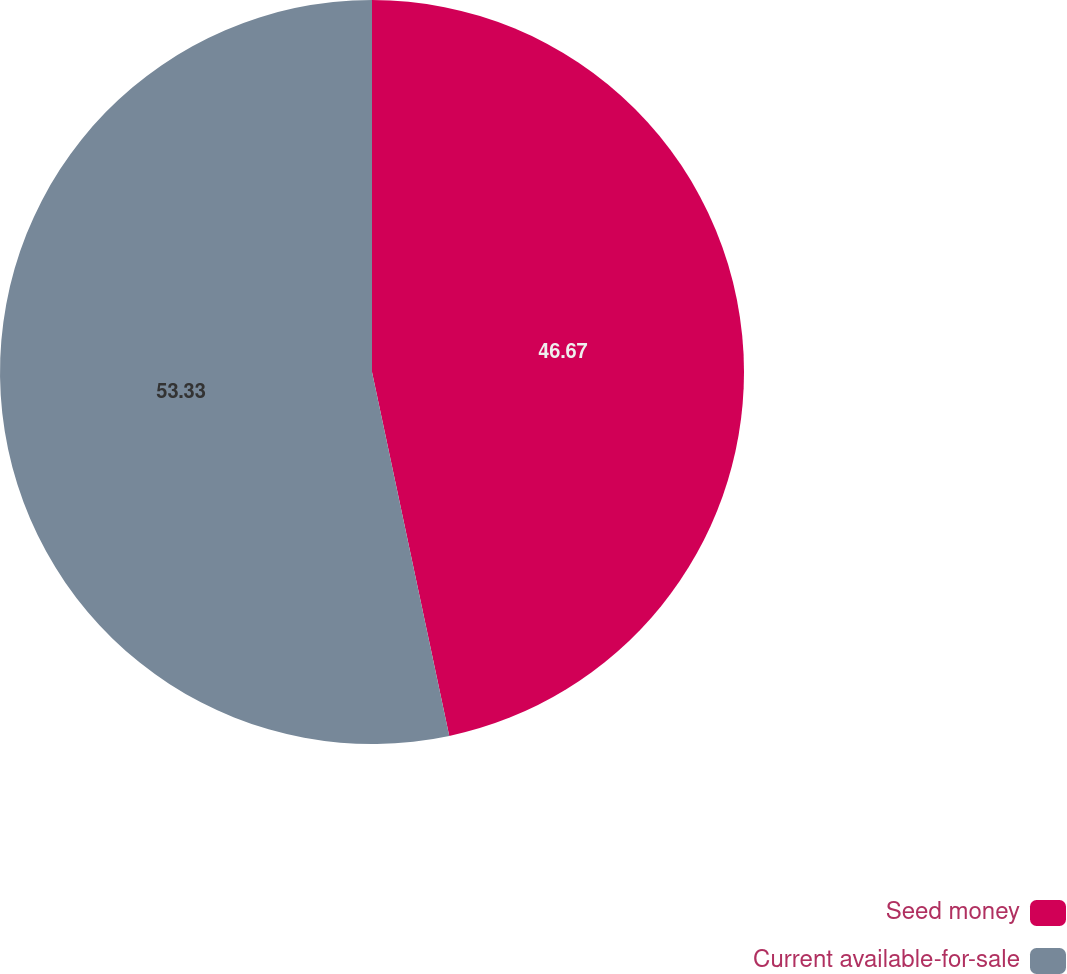Convert chart. <chart><loc_0><loc_0><loc_500><loc_500><pie_chart><fcel>Seed money<fcel>Current available-for-sale<nl><fcel>46.67%<fcel>53.33%<nl></chart> 